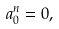<formula> <loc_0><loc_0><loc_500><loc_500>a _ { 0 } ^ { n } = 0 ,</formula> 